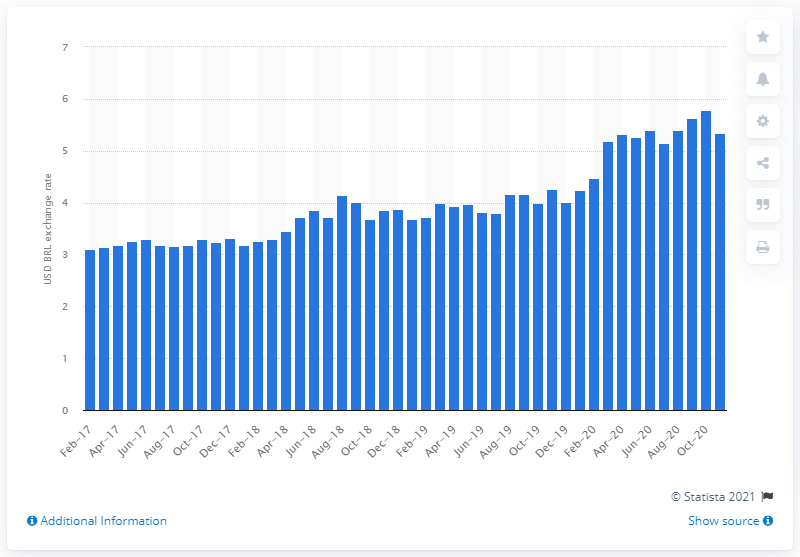List a handful of essential elements in this visual. At the end of November 2020, one US dollar could buy 5.34 Brazilian reals. 